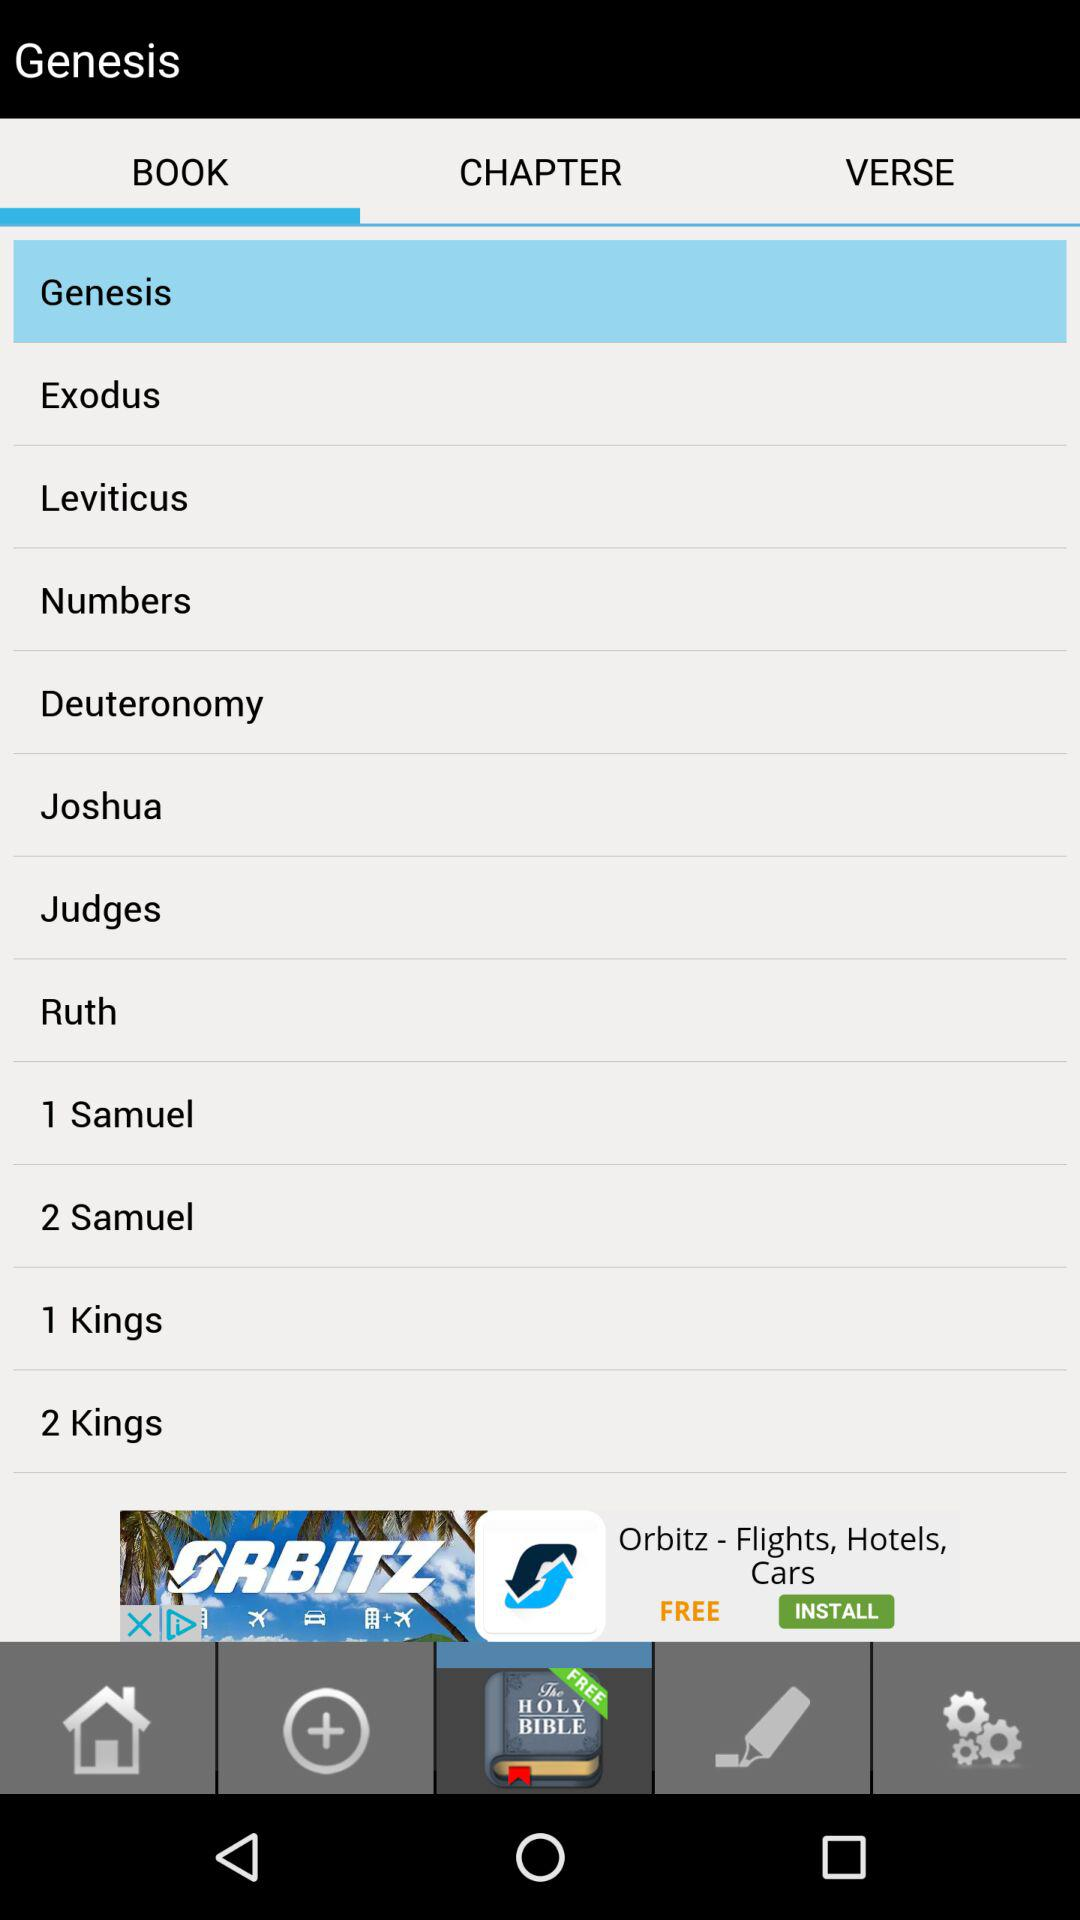What time is it?
When the provided information is insufficient, respond with <no answer>. <no answer> 